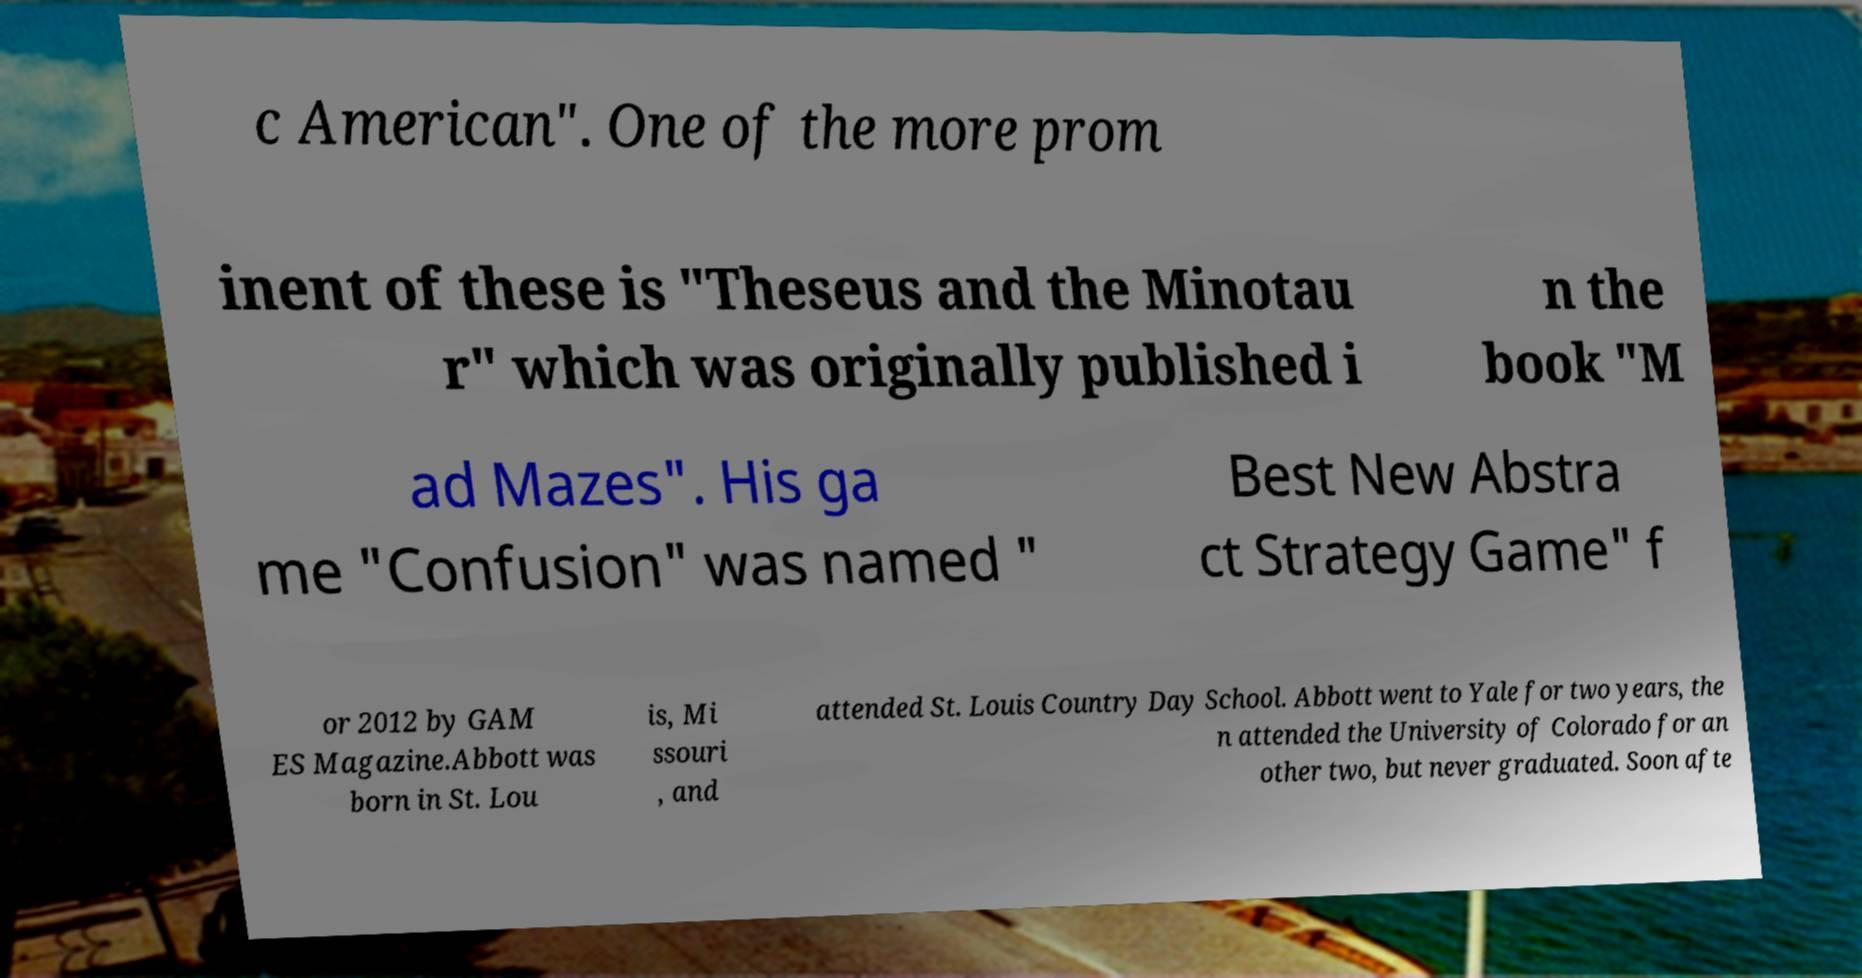There's text embedded in this image that I need extracted. Can you transcribe it verbatim? c American". One of the more prom inent of these is "Theseus and the Minotau r" which was originally published i n the book "M ad Mazes". His ga me "Confusion" was named " Best New Abstra ct Strategy Game" f or 2012 by GAM ES Magazine.Abbott was born in St. Lou is, Mi ssouri , and attended St. Louis Country Day School. Abbott went to Yale for two years, the n attended the University of Colorado for an other two, but never graduated. Soon afte 